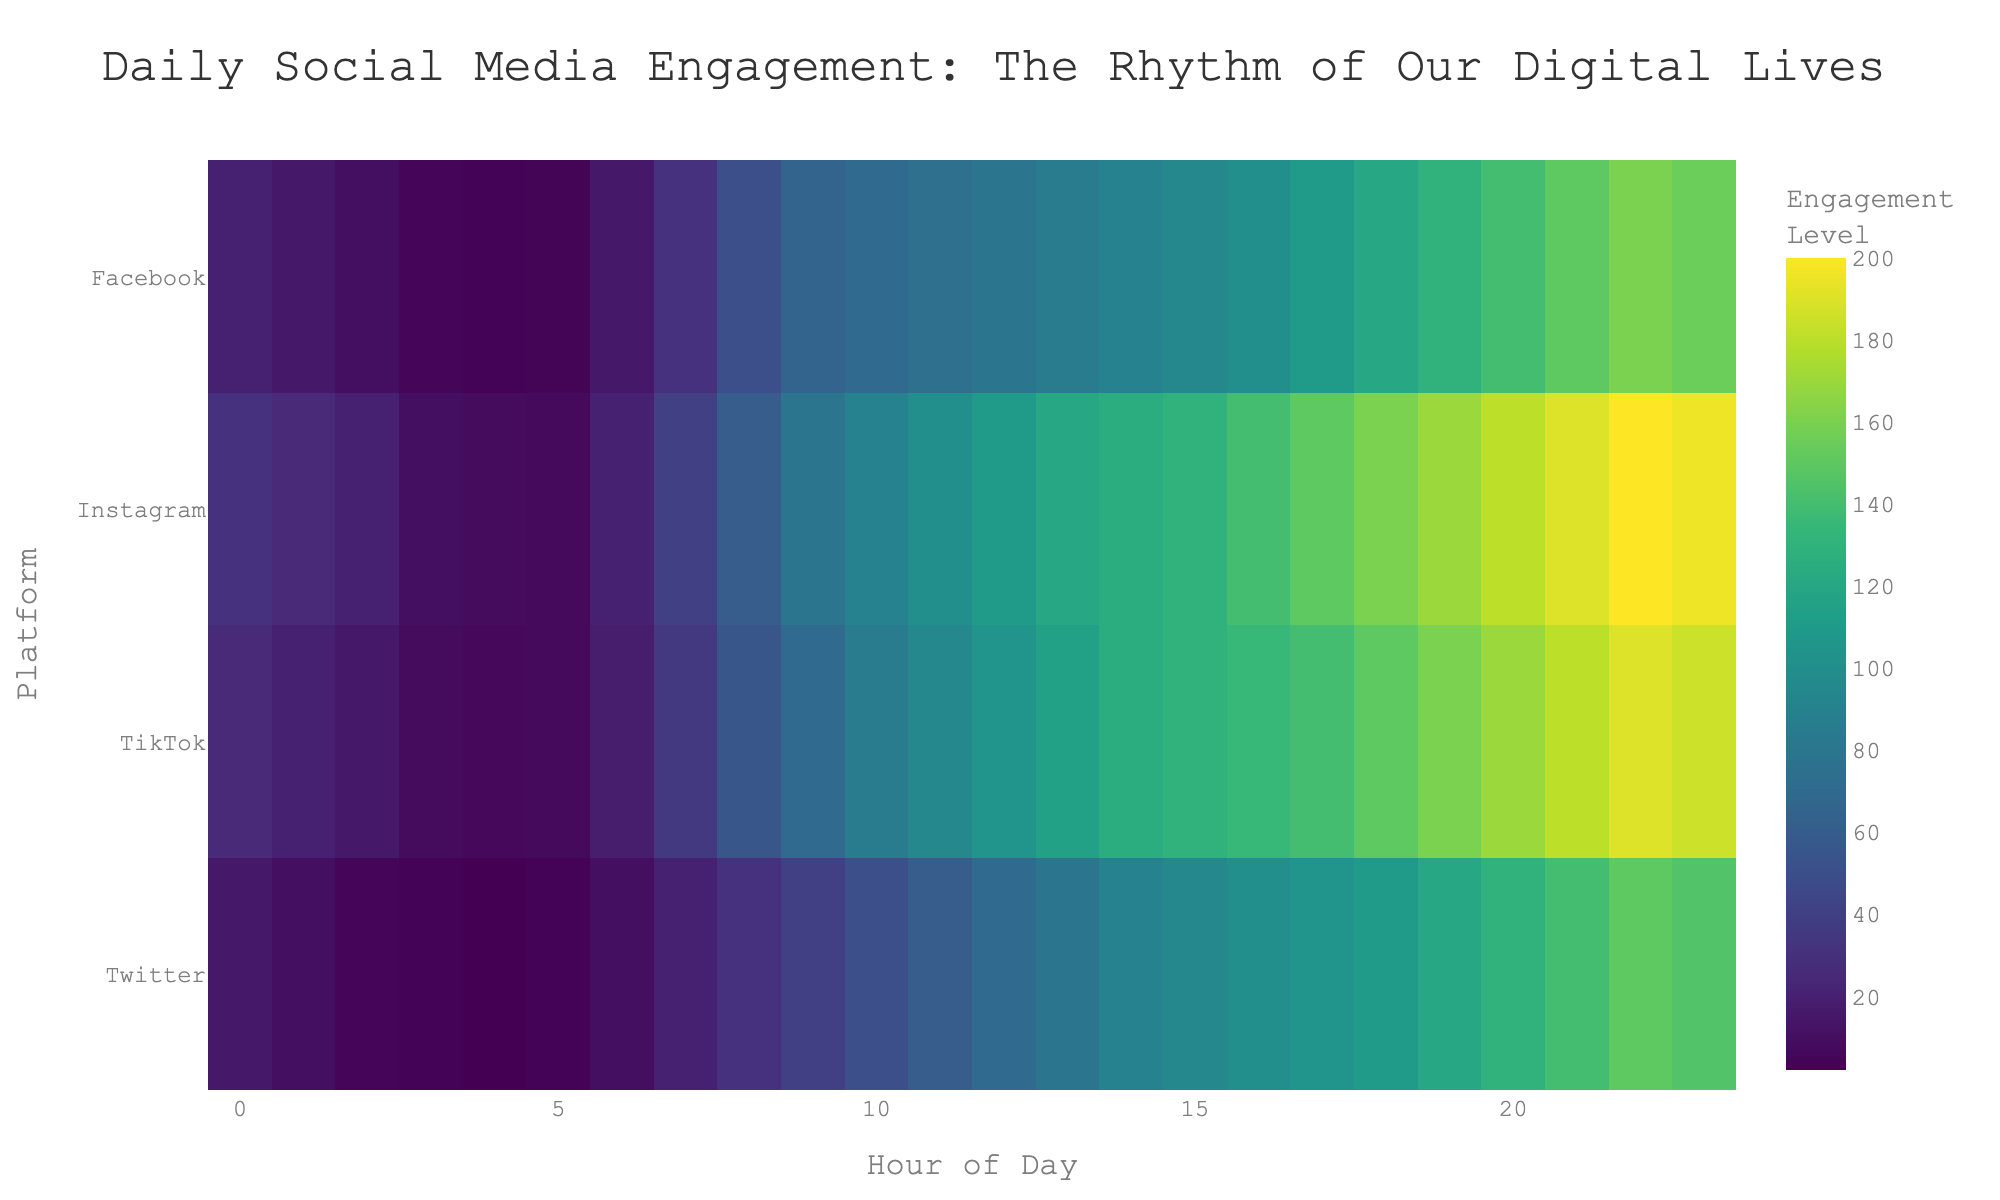compare the engagement at hour 10 across all platforms, which has the highest? Check the engagement values at hour 10 for all platforms: Facebook (70), Instagram (90), Twitter (50), TikTok (85). The highest value is for Instagram at 90.
Answer: Instagram what is the total engagement for Twitter from hour 0 to hour 3? Sum up the engagement values for Twitter from hour 0 to hour 3: 15 (hour 0) + 10 (hour 1) + 5 (hour 2) + 3 (hour 3) = 33.
Answer: 33 what's the difference in engagement between hour 12 and hour 18 for TikTok? Compare the engagement values at hour 12 (105) and hour 18 (150) for TikTok: 150 - 105 = 45.
Answer: 45 during which hour is Facebook engagement exactly halfway between its highest and lowest engagement levels? The highest engagement level is 160 (hour 22), and the lowest is 3 (hour 4). Halfway between these is (160 + 3)/2 = 81.5. Looking at the heatmap, the closest value to 81.5 is at hour 13 with 85.
Answer: 13 what is the average engagement for Instagram during the evening hours (18 to 23)? Sum up engagement values for Instagram from hour 18 to hour 23 and divide by 6: (160 + 170 + 180 + 190 + 200 + 195) / 6 = 1095 / 6 = 182.5.
Answer: 182.5 how does Twitter's engagement at hour 9 compare to TikTok's engagement at the same hour? Compare engagement levels at hour 9 for Twitter (40) and TikTok (70). TikTok's engagement is higher.
Answer: TikTok is higher what pattern can be observed in the engagement levels for platforms in the early morning hours (midnight to 6 am)? Observing the heatmap from hours 0 to 6 for all platforms, engagement tends to be lower during these hours compared to the rest of the day, indicated by relatively lighter colors.
Answer: Lower engagement 